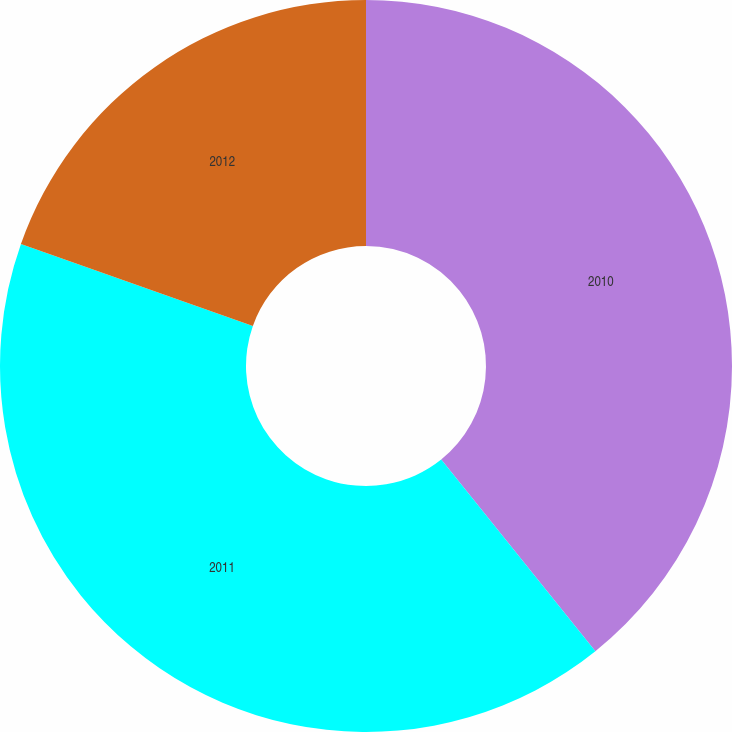<chart> <loc_0><loc_0><loc_500><loc_500><pie_chart><fcel>2010<fcel>2011<fcel>2012<nl><fcel>39.22%<fcel>41.19%<fcel>19.59%<nl></chart> 